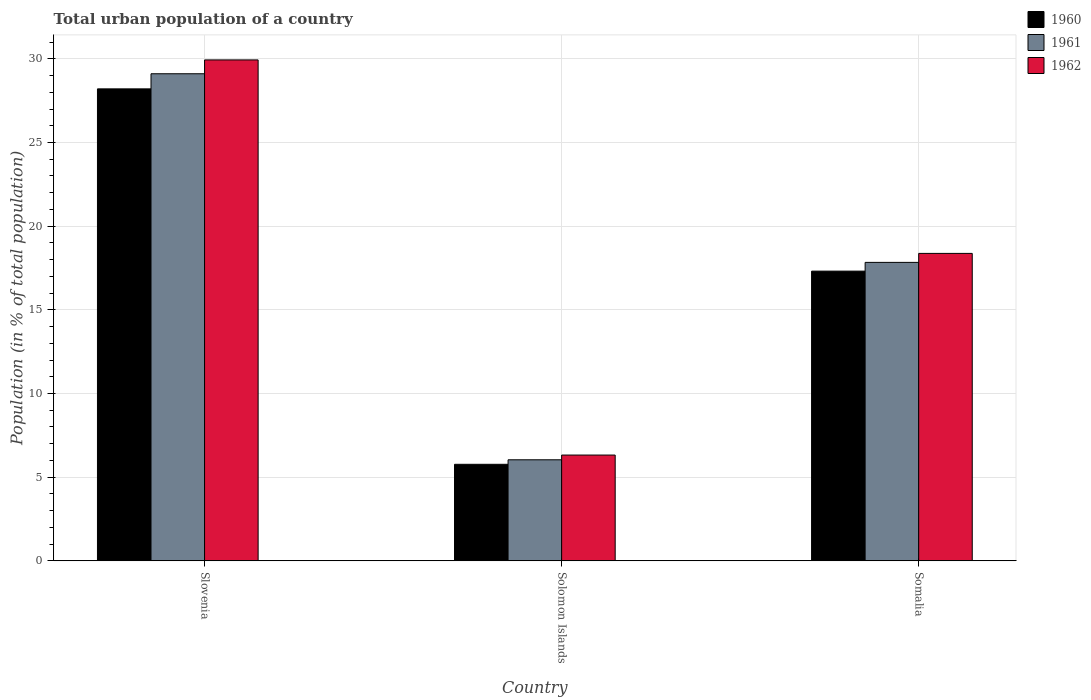How many different coloured bars are there?
Ensure brevity in your answer.  3. How many groups of bars are there?
Keep it short and to the point. 3. Are the number of bars on each tick of the X-axis equal?
Your response must be concise. Yes. How many bars are there on the 2nd tick from the left?
Ensure brevity in your answer.  3. How many bars are there on the 1st tick from the right?
Keep it short and to the point. 3. What is the label of the 3rd group of bars from the left?
Offer a terse response. Somalia. What is the urban population in 1962 in Slovenia?
Offer a terse response. 29.93. Across all countries, what is the maximum urban population in 1961?
Give a very brief answer. 29.11. Across all countries, what is the minimum urban population in 1961?
Your response must be concise. 6.04. In which country was the urban population in 1962 maximum?
Make the answer very short. Slovenia. In which country was the urban population in 1960 minimum?
Provide a short and direct response. Solomon Islands. What is the total urban population in 1960 in the graph?
Your response must be concise. 51.28. What is the difference between the urban population in 1962 in Solomon Islands and that in Somalia?
Your response must be concise. -12.05. What is the difference between the urban population in 1961 in Somalia and the urban population in 1962 in Slovenia?
Your response must be concise. -12.1. What is the average urban population in 1961 per country?
Give a very brief answer. 17.66. What is the difference between the urban population of/in 1960 and urban population of/in 1961 in Somalia?
Keep it short and to the point. -0.52. In how many countries, is the urban population in 1962 greater than 8 %?
Your answer should be compact. 2. What is the ratio of the urban population in 1961 in Slovenia to that in Somalia?
Make the answer very short. 1.63. What is the difference between the highest and the second highest urban population in 1962?
Keep it short and to the point. -11.56. What is the difference between the highest and the lowest urban population in 1961?
Your answer should be very brief. 23.07. Is the sum of the urban population in 1962 in Slovenia and Somalia greater than the maximum urban population in 1960 across all countries?
Offer a very short reply. Yes. What does the 2nd bar from the left in Somalia represents?
Give a very brief answer. 1961. Is it the case that in every country, the sum of the urban population in 1962 and urban population in 1961 is greater than the urban population in 1960?
Your answer should be compact. Yes. How many bars are there?
Offer a very short reply. 9. Are all the bars in the graph horizontal?
Offer a very short reply. No. How many countries are there in the graph?
Offer a very short reply. 3. What is the difference between two consecutive major ticks on the Y-axis?
Offer a very short reply. 5. Are the values on the major ticks of Y-axis written in scientific E-notation?
Keep it short and to the point. No. Does the graph contain any zero values?
Provide a short and direct response. No. How are the legend labels stacked?
Your response must be concise. Vertical. What is the title of the graph?
Your answer should be very brief. Total urban population of a country. What is the label or title of the Y-axis?
Provide a succinct answer. Population (in % of total population). What is the Population (in % of total population) of 1960 in Slovenia?
Offer a terse response. 28.2. What is the Population (in % of total population) in 1961 in Slovenia?
Give a very brief answer. 29.11. What is the Population (in % of total population) in 1962 in Slovenia?
Give a very brief answer. 29.93. What is the Population (in % of total population) of 1960 in Solomon Islands?
Your answer should be very brief. 5.77. What is the Population (in % of total population) in 1961 in Solomon Islands?
Your answer should be compact. 6.04. What is the Population (in % of total population) in 1962 in Solomon Islands?
Make the answer very short. 6.32. What is the Population (in % of total population) in 1960 in Somalia?
Ensure brevity in your answer.  17.31. What is the Population (in % of total population) in 1961 in Somalia?
Offer a very short reply. 17.84. What is the Population (in % of total population) of 1962 in Somalia?
Give a very brief answer. 18.37. Across all countries, what is the maximum Population (in % of total population) of 1960?
Your answer should be very brief. 28.2. Across all countries, what is the maximum Population (in % of total population) of 1961?
Offer a terse response. 29.11. Across all countries, what is the maximum Population (in % of total population) in 1962?
Ensure brevity in your answer.  29.93. Across all countries, what is the minimum Population (in % of total population) in 1960?
Provide a short and direct response. 5.77. Across all countries, what is the minimum Population (in % of total population) in 1961?
Your answer should be very brief. 6.04. Across all countries, what is the minimum Population (in % of total population) of 1962?
Your answer should be very brief. 6.32. What is the total Population (in % of total population) in 1960 in the graph?
Give a very brief answer. 51.28. What is the total Population (in % of total population) of 1961 in the graph?
Provide a short and direct response. 52.98. What is the total Population (in % of total population) in 1962 in the graph?
Provide a short and direct response. 54.63. What is the difference between the Population (in % of total population) in 1960 in Slovenia and that in Solomon Islands?
Keep it short and to the point. 22.44. What is the difference between the Population (in % of total population) in 1961 in Slovenia and that in Solomon Islands?
Make the answer very short. 23.07. What is the difference between the Population (in % of total population) of 1962 in Slovenia and that in Solomon Islands?
Offer a terse response. 23.61. What is the difference between the Population (in % of total population) in 1960 in Slovenia and that in Somalia?
Keep it short and to the point. 10.89. What is the difference between the Population (in % of total population) in 1961 in Slovenia and that in Somalia?
Ensure brevity in your answer.  11.27. What is the difference between the Population (in % of total population) in 1962 in Slovenia and that in Somalia?
Give a very brief answer. 11.56. What is the difference between the Population (in % of total population) of 1960 in Solomon Islands and that in Somalia?
Your answer should be very brief. -11.54. What is the difference between the Population (in % of total population) of 1961 in Solomon Islands and that in Somalia?
Give a very brief answer. -11.8. What is the difference between the Population (in % of total population) of 1962 in Solomon Islands and that in Somalia?
Provide a succinct answer. -12.05. What is the difference between the Population (in % of total population) of 1960 in Slovenia and the Population (in % of total population) of 1961 in Solomon Islands?
Your answer should be compact. 22.17. What is the difference between the Population (in % of total population) of 1960 in Slovenia and the Population (in % of total population) of 1962 in Solomon Islands?
Ensure brevity in your answer.  21.88. What is the difference between the Population (in % of total population) in 1961 in Slovenia and the Population (in % of total population) in 1962 in Solomon Islands?
Your answer should be very brief. 22.79. What is the difference between the Population (in % of total population) of 1960 in Slovenia and the Population (in % of total population) of 1961 in Somalia?
Offer a terse response. 10.37. What is the difference between the Population (in % of total population) in 1960 in Slovenia and the Population (in % of total population) in 1962 in Somalia?
Ensure brevity in your answer.  9.83. What is the difference between the Population (in % of total population) in 1961 in Slovenia and the Population (in % of total population) in 1962 in Somalia?
Provide a short and direct response. 10.73. What is the difference between the Population (in % of total population) in 1960 in Solomon Islands and the Population (in % of total population) in 1961 in Somalia?
Make the answer very short. -12.07. What is the difference between the Population (in % of total population) in 1960 in Solomon Islands and the Population (in % of total population) in 1962 in Somalia?
Provide a short and direct response. -12.6. What is the difference between the Population (in % of total population) in 1961 in Solomon Islands and the Population (in % of total population) in 1962 in Somalia?
Your response must be concise. -12.33. What is the average Population (in % of total population) of 1960 per country?
Ensure brevity in your answer.  17.09. What is the average Population (in % of total population) in 1961 per country?
Provide a short and direct response. 17.66. What is the average Population (in % of total population) in 1962 per country?
Your answer should be very brief. 18.21. What is the difference between the Population (in % of total population) of 1960 and Population (in % of total population) of 1961 in Slovenia?
Offer a terse response. -0.9. What is the difference between the Population (in % of total population) of 1960 and Population (in % of total population) of 1962 in Slovenia?
Your answer should be compact. -1.73. What is the difference between the Population (in % of total population) of 1961 and Population (in % of total population) of 1962 in Slovenia?
Keep it short and to the point. -0.83. What is the difference between the Population (in % of total population) in 1960 and Population (in % of total population) in 1961 in Solomon Islands?
Provide a succinct answer. -0.27. What is the difference between the Population (in % of total population) of 1960 and Population (in % of total population) of 1962 in Solomon Islands?
Offer a very short reply. -0.55. What is the difference between the Population (in % of total population) in 1961 and Population (in % of total population) in 1962 in Solomon Islands?
Provide a short and direct response. -0.28. What is the difference between the Population (in % of total population) of 1960 and Population (in % of total population) of 1961 in Somalia?
Your answer should be compact. -0.52. What is the difference between the Population (in % of total population) in 1960 and Population (in % of total population) in 1962 in Somalia?
Make the answer very short. -1.06. What is the difference between the Population (in % of total population) of 1961 and Population (in % of total population) of 1962 in Somalia?
Your response must be concise. -0.54. What is the ratio of the Population (in % of total population) in 1960 in Slovenia to that in Solomon Islands?
Keep it short and to the point. 4.89. What is the ratio of the Population (in % of total population) in 1961 in Slovenia to that in Solomon Islands?
Provide a short and direct response. 4.82. What is the ratio of the Population (in % of total population) of 1962 in Slovenia to that in Solomon Islands?
Your answer should be very brief. 4.74. What is the ratio of the Population (in % of total population) of 1960 in Slovenia to that in Somalia?
Provide a short and direct response. 1.63. What is the ratio of the Population (in % of total population) in 1961 in Slovenia to that in Somalia?
Your answer should be very brief. 1.63. What is the ratio of the Population (in % of total population) in 1962 in Slovenia to that in Somalia?
Your answer should be very brief. 1.63. What is the ratio of the Population (in % of total population) in 1960 in Solomon Islands to that in Somalia?
Your response must be concise. 0.33. What is the ratio of the Population (in % of total population) of 1961 in Solomon Islands to that in Somalia?
Provide a succinct answer. 0.34. What is the ratio of the Population (in % of total population) of 1962 in Solomon Islands to that in Somalia?
Your answer should be compact. 0.34. What is the difference between the highest and the second highest Population (in % of total population) in 1960?
Your response must be concise. 10.89. What is the difference between the highest and the second highest Population (in % of total population) in 1961?
Keep it short and to the point. 11.27. What is the difference between the highest and the second highest Population (in % of total population) of 1962?
Give a very brief answer. 11.56. What is the difference between the highest and the lowest Population (in % of total population) of 1960?
Your response must be concise. 22.44. What is the difference between the highest and the lowest Population (in % of total population) in 1961?
Give a very brief answer. 23.07. What is the difference between the highest and the lowest Population (in % of total population) in 1962?
Provide a succinct answer. 23.61. 